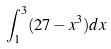<formula> <loc_0><loc_0><loc_500><loc_500>\int _ { 1 } ^ { 3 } ( 2 7 - x ^ { 3 } ) d x</formula> 